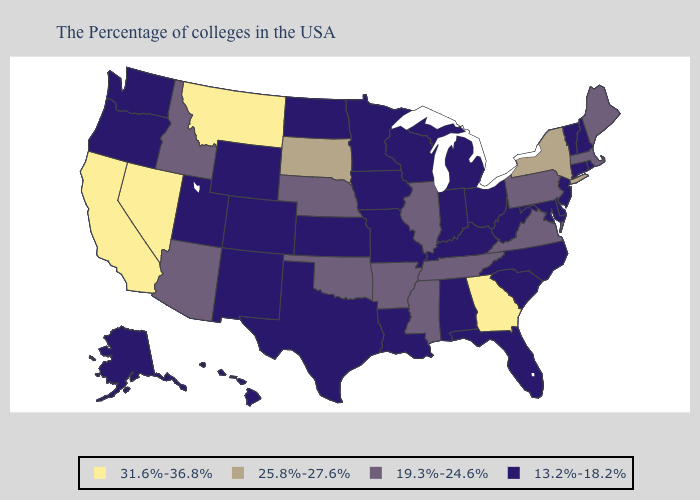Name the states that have a value in the range 31.6%-36.8%?
Answer briefly. Georgia, Montana, Nevada, California. What is the highest value in the West ?
Keep it brief. 31.6%-36.8%. Among the states that border Arizona , which have the lowest value?
Answer briefly. Colorado, New Mexico, Utah. What is the highest value in the MidWest ?
Be succinct. 25.8%-27.6%. Name the states that have a value in the range 25.8%-27.6%?
Short answer required. New York, South Dakota. What is the value of Utah?
Short answer required. 13.2%-18.2%. Name the states that have a value in the range 25.8%-27.6%?
Answer briefly. New York, South Dakota. Does Mississippi have the lowest value in the USA?
Short answer required. No. What is the value of Utah?
Write a very short answer. 13.2%-18.2%. Name the states that have a value in the range 19.3%-24.6%?
Be succinct. Maine, Massachusetts, Pennsylvania, Virginia, Tennessee, Illinois, Mississippi, Arkansas, Nebraska, Oklahoma, Arizona, Idaho. What is the value of Iowa?
Keep it brief. 13.2%-18.2%. Does Wyoming have a lower value than Ohio?
Be succinct. No. Which states have the lowest value in the South?
Keep it brief. Delaware, Maryland, North Carolina, South Carolina, West Virginia, Florida, Kentucky, Alabama, Louisiana, Texas. What is the lowest value in the South?
Concise answer only. 13.2%-18.2%. What is the value of Maryland?
Give a very brief answer. 13.2%-18.2%. 